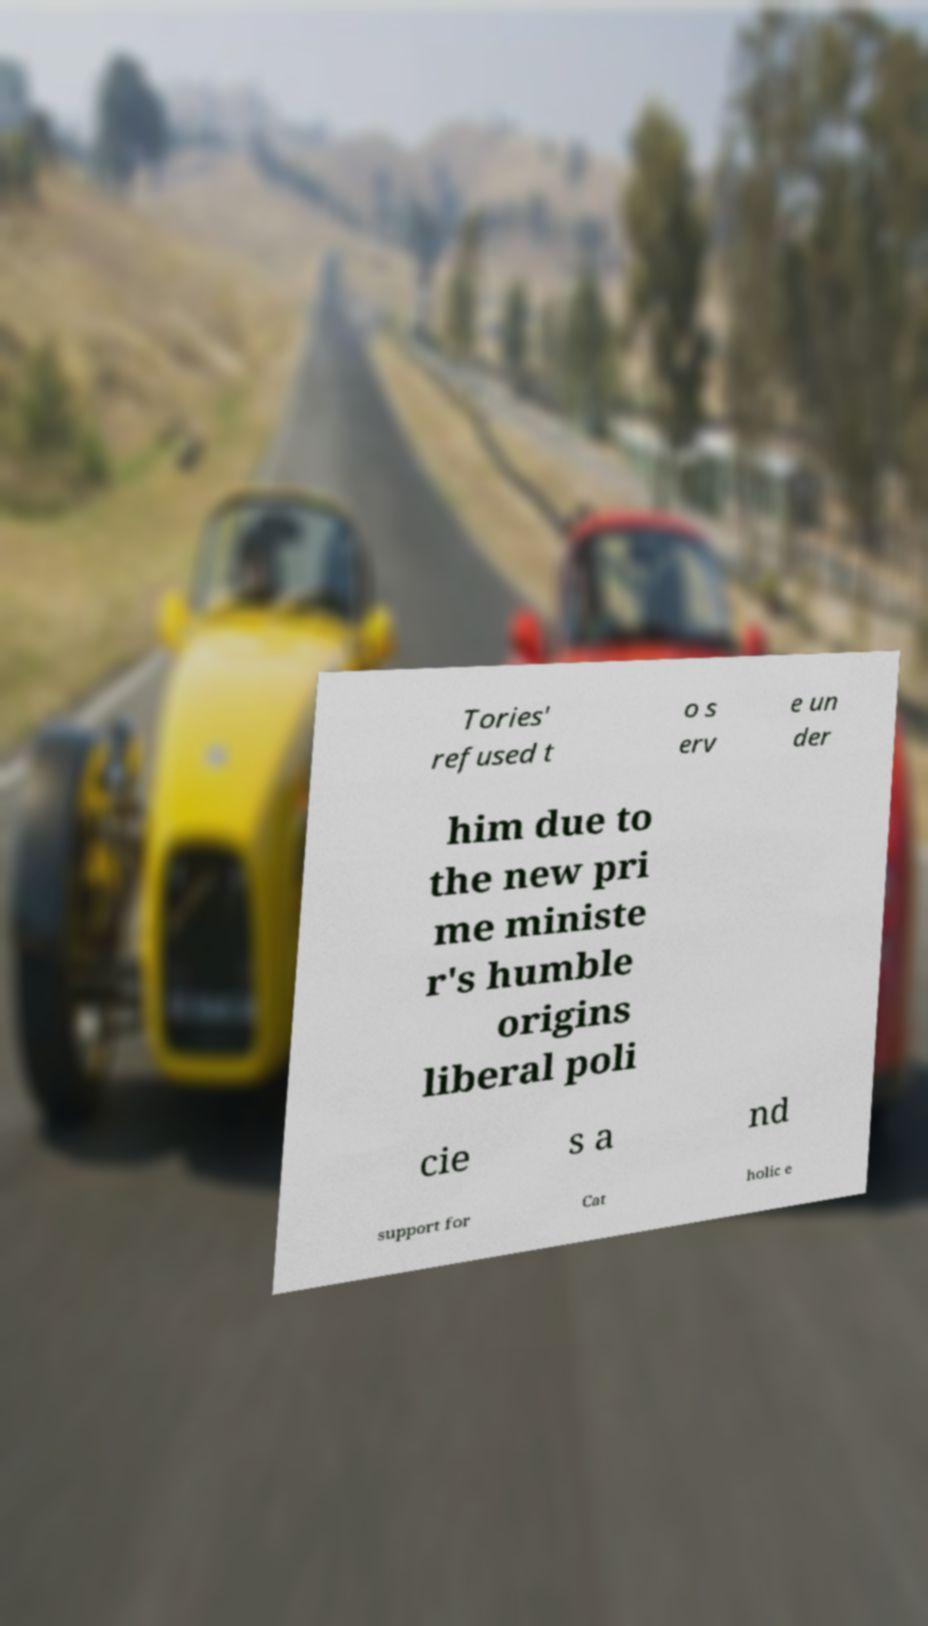What messages or text are displayed in this image? I need them in a readable, typed format. Tories' refused t o s erv e un der him due to the new pri me ministe r's humble origins liberal poli cie s a nd support for Cat holic e 